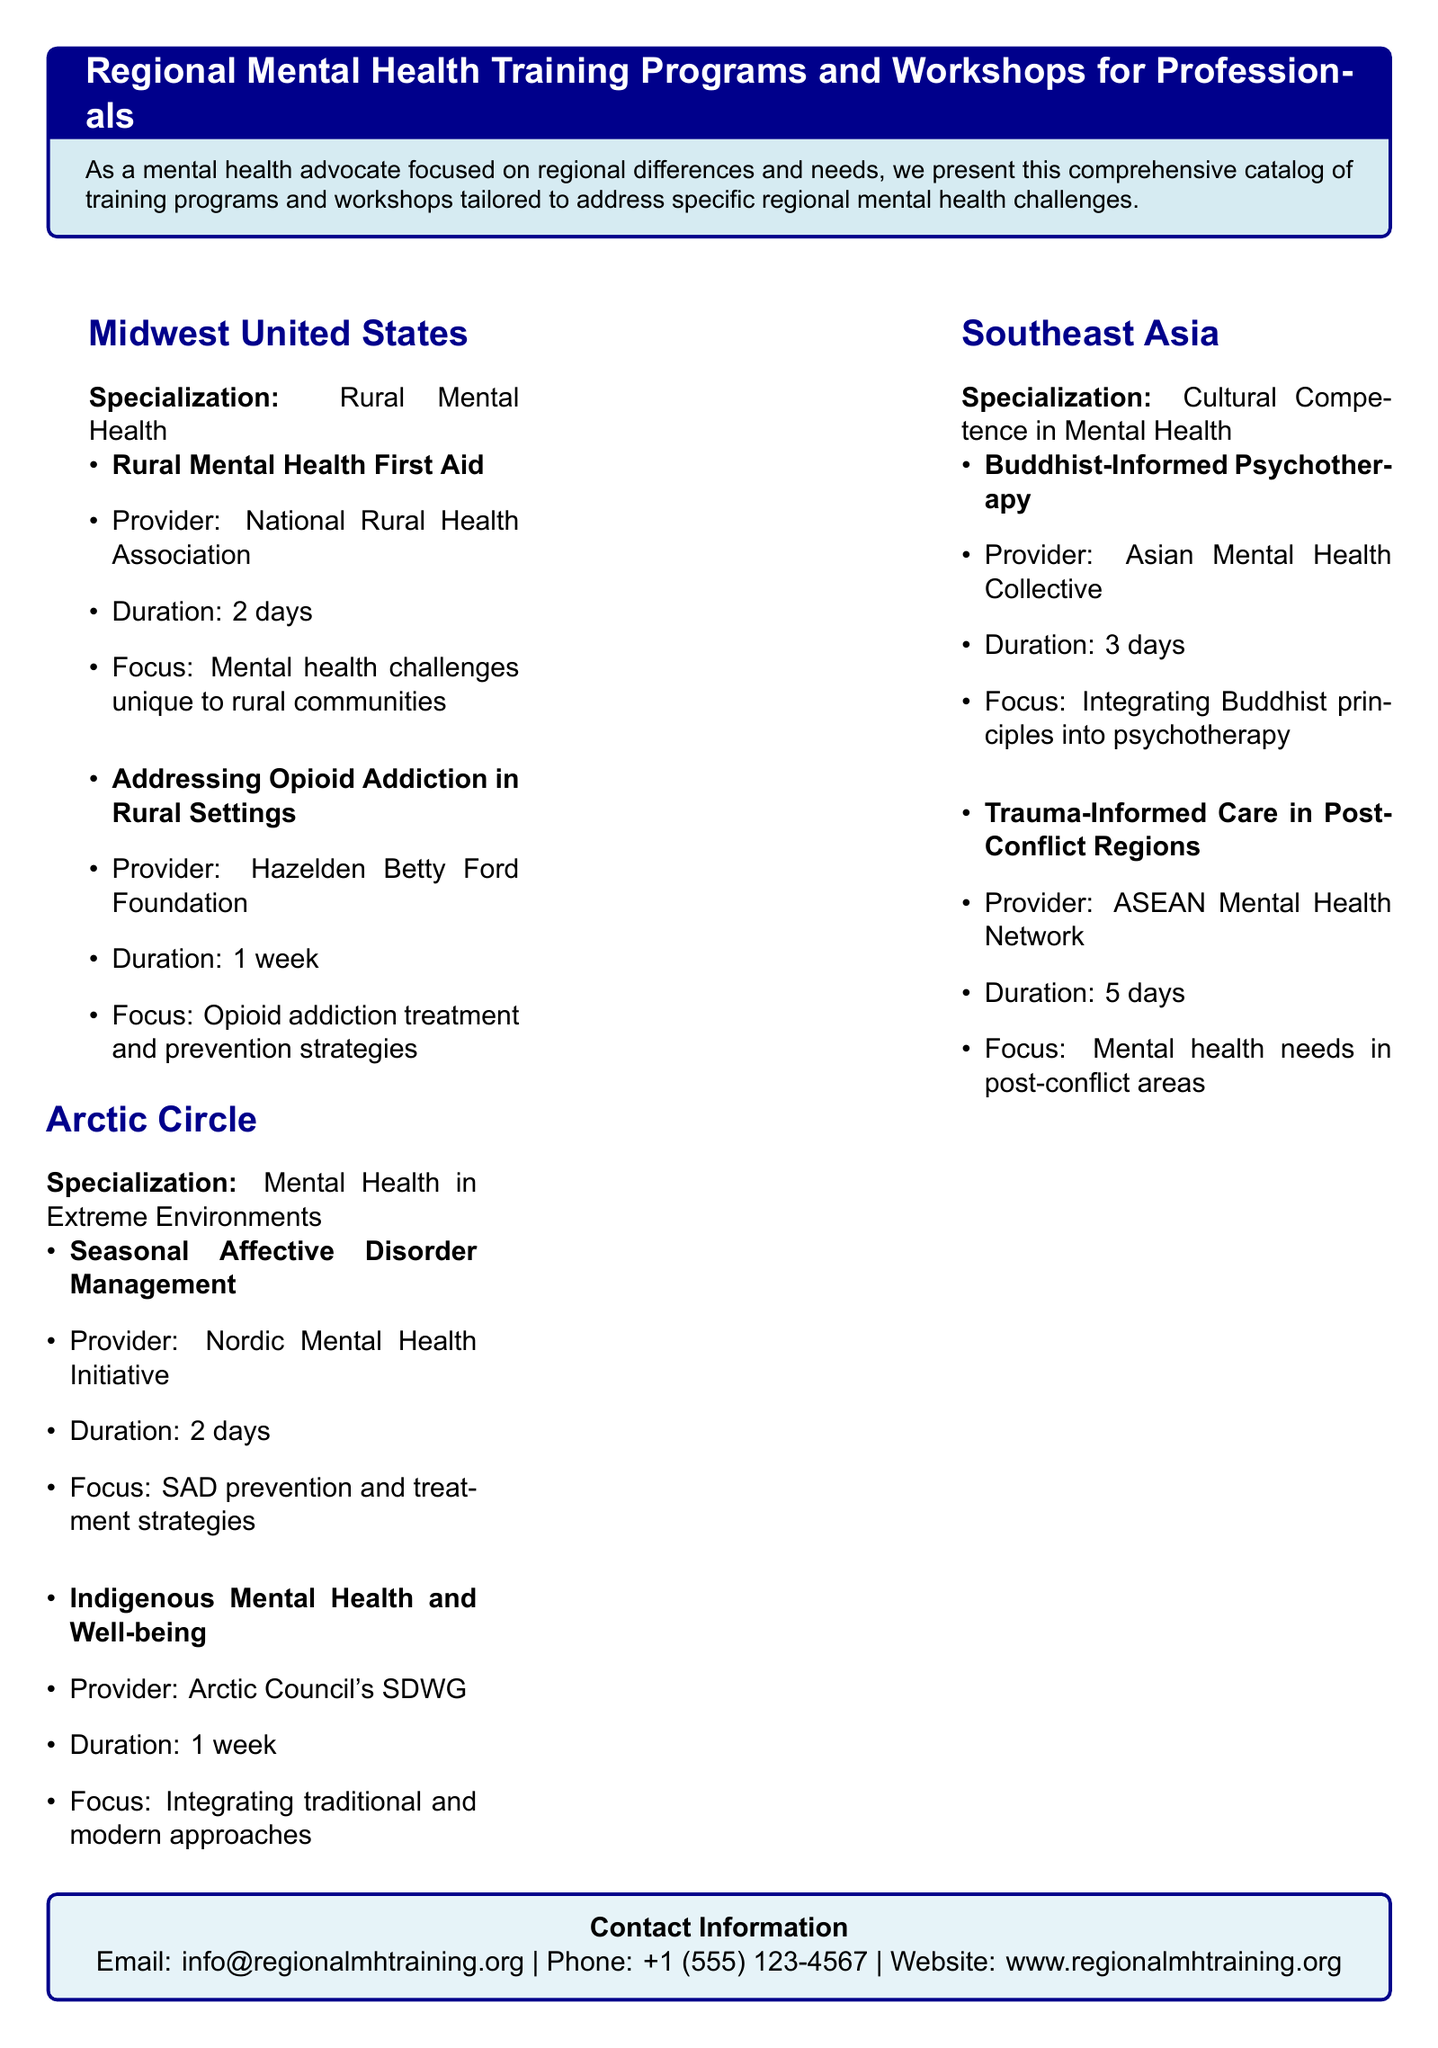What is the specialization of Midwest United States training programs? The specialization focuses on mental health challenges unique to rural communities.
Answer: Rural Mental Health What is the duration of the "Trauma-Informed Care in Post-Conflict Regions" workshop? The document indicates that this workshop lasts for 5 days.
Answer: 5 days Who provides the "Indigenous Mental Health and Well-being" training? The document states that it is provided by the Arctic Council's SDWG.
Answer: Arctic Council's SDWG How many days is the "Seasonal Affective Disorder Management" training? The duration for this training is mentioned as 2 days.
Answer: 2 days What is a key focus area of the Southeast Asia training programs? The key focus area highlighted is cultural competence in mental health.
Answer: Cultural Competence in Mental Health What type of addiction does the Midwest program specifically address? The program focuses on addressing opioid addiction in rural settings.
Answer: Opioid addiction How long is the "Rural Mental Health First Aid" training? The duration stated for this training program is 2 days.
Answer: 2 days Which organization provides training on integrating Buddhist principles? The Asian Mental Health Collective is the provider of this training.
Answer: Asian Mental Health Collective What kind of strategies does the "Addressing Opioid Addiction in Rural Settings" workshop emphasize? The workshop emphasizes treatment and prevention strategies related to opioid addiction.
Answer: Treatment and prevention strategies 